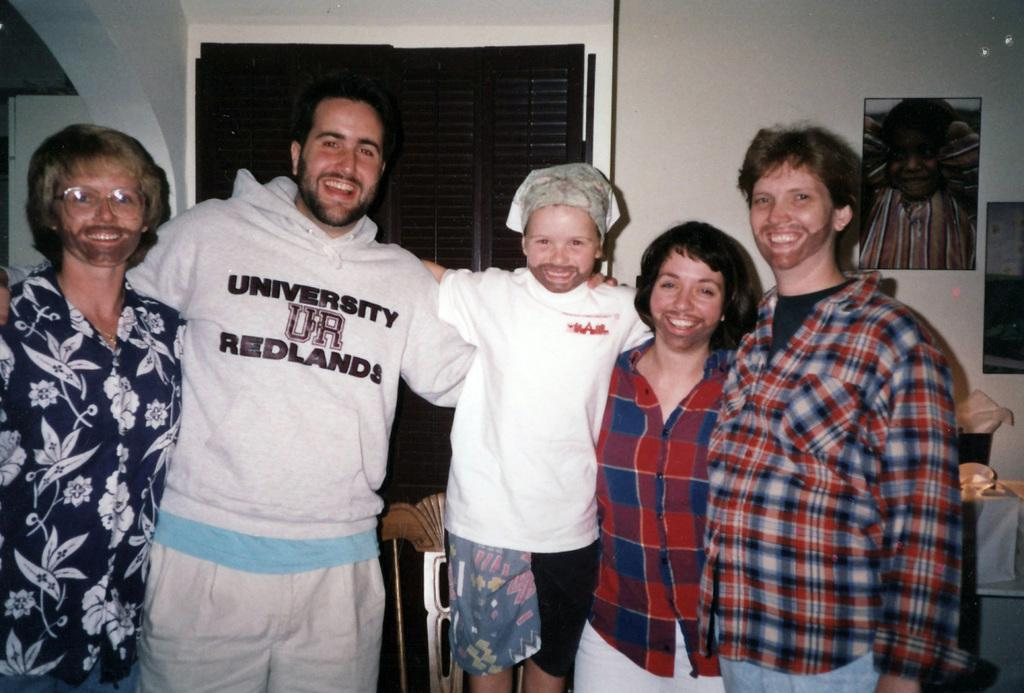How many people are standing in the image? There are 5 people standing in the image. What is unique about the position of one of the people? One person is standing on a chair. What is the person standing on the chair wearing? The person standing on the chair is wearing a white t-shirt. What can be seen on the wall behind the people? There are photo frames on the wall behind the people. What type of debt is being discussed by the people in the image? There is no indication of any debt being discussed in the image. Can you tell me the color of the bedspread in the bedroom shown in the image? There is no bedroom shown in the image. What chess piece is the person standing on the chair holding in the image? There is no chess piece visible in the image. 